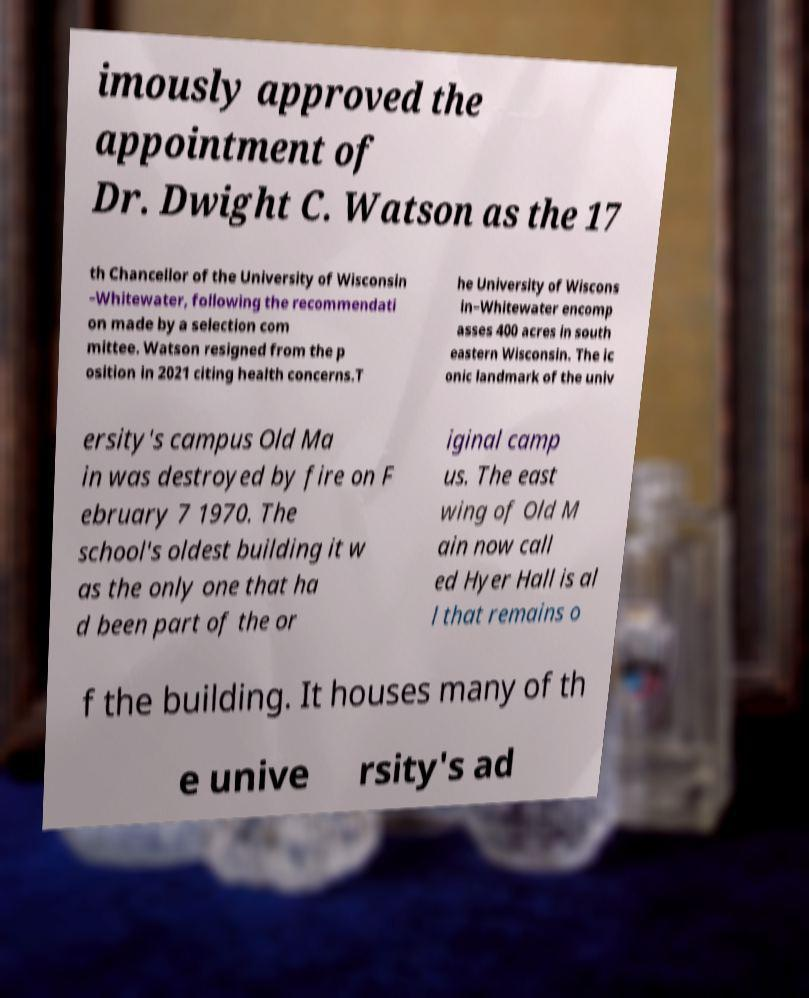For documentation purposes, I need the text within this image transcribed. Could you provide that? imously approved the appointment of Dr. Dwight C. Watson as the 17 th Chancellor of the University of Wisconsin –Whitewater, following the recommendati on made by a selection com mittee. Watson resigned from the p osition in 2021 citing health concerns.T he University of Wiscons in–Whitewater encomp asses 400 acres in south eastern Wisconsin. The ic onic landmark of the univ ersity's campus Old Ma in was destroyed by fire on F ebruary 7 1970. The school's oldest building it w as the only one that ha d been part of the or iginal camp us. The east wing of Old M ain now call ed Hyer Hall is al l that remains o f the building. It houses many of th e unive rsity's ad 